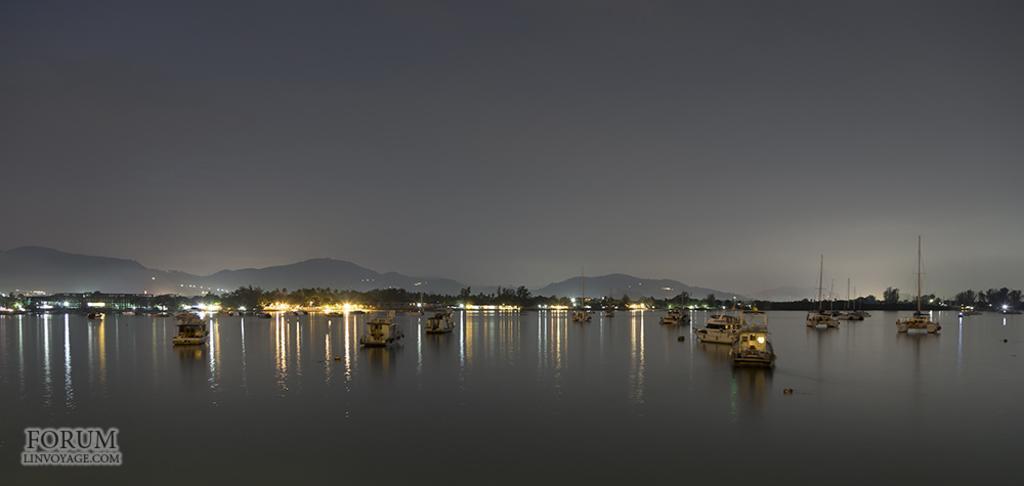In one or two sentences, can you explain what this image depicts? In this image I can see some boards on the water. In the background I can see many trees, mountains and the sky. I can also see the watermark in the image. 